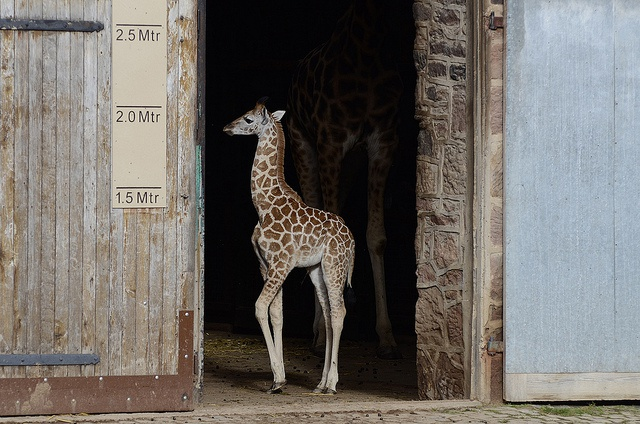Describe the objects in this image and their specific colors. I can see a giraffe in darkgray, black, gray, and maroon tones in this image. 